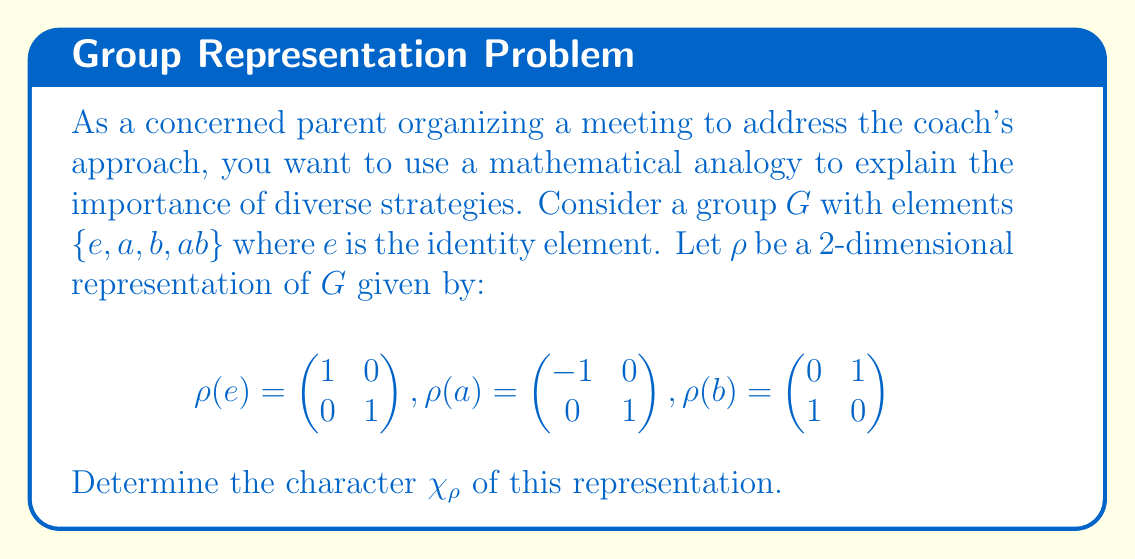What is the answer to this math problem? To determine the character of the representation, we need to calculate the trace of each matrix in the representation:

1) For $\rho(e)$:
   $\chi_\rho(e) = \text{Tr}(\rho(e)) = 1 + 1 = 2$

2) For $\rho(a)$:
   $\chi_\rho(a) = \text{Tr}(\rho(a)) = -1 + 1 = 0$

3) For $\rho(b)$:
   $\chi_\rho(b) = \text{Tr}(\rho(b)) = 0 + 1 = 1$

4) For $\rho(ab)$, we first need to calculate the matrix:
   $\rho(ab) = \rho(a)\rho(b) = \begin{pmatrix} -1 & 0 \\ 0 & 1 \end{pmatrix} \begin{pmatrix} 0 & 1 \\ 1 & 0 \end{pmatrix} = \begin{pmatrix} 0 & -1 \\ 1 & 0 \end{pmatrix}$
   
   Now we can calculate its trace:
   $\chi_\rho(ab) = \text{Tr}(\rho(ab)) = 0 + 0 = 0$

Therefore, the character $\chi_\rho$ of the representation is:

$\chi_\rho = (2, 0, 1, 0)$

where the values correspond to the group elements in the order $(e, a, b, ab)$.
Answer: $\chi_\rho = (2, 0, 1, 0)$ 